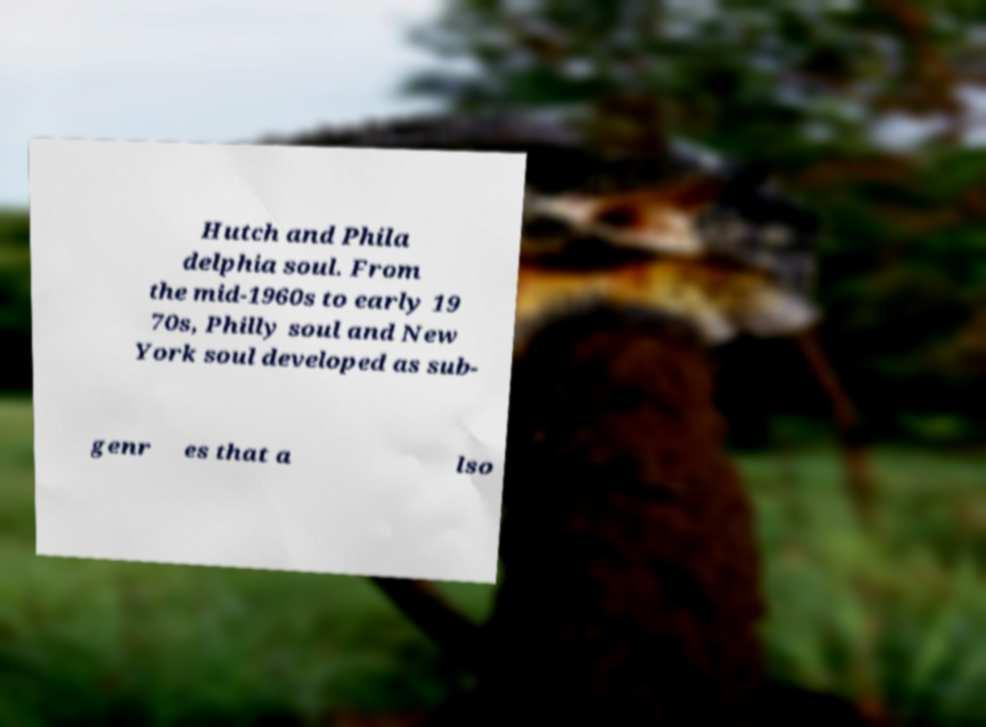There's text embedded in this image that I need extracted. Can you transcribe it verbatim? Hutch and Phila delphia soul. From the mid-1960s to early 19 70s, Philly soul and New York soul developed as sub- genr es that a lso 